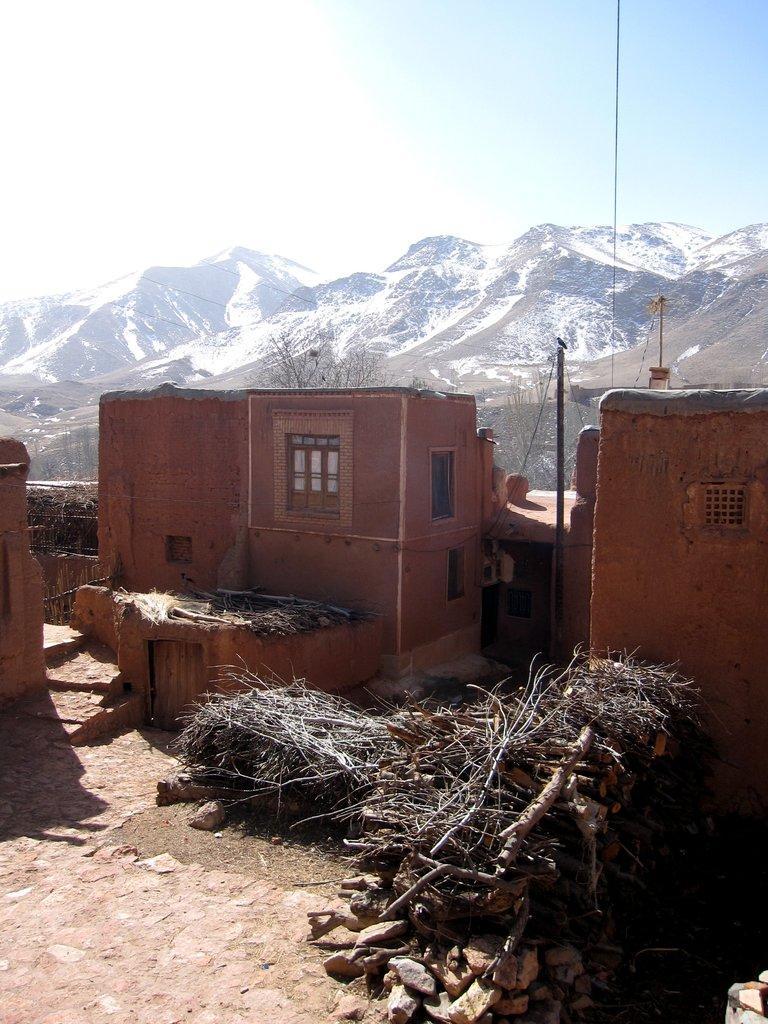How would you summarize this image in a sentence or two? In this image we can see some buildings with windows. On the bottom of the image we can see some stones and branches of the trees. On the backside we can see the mountains covered with the snow and the sky which looks cloudy. 